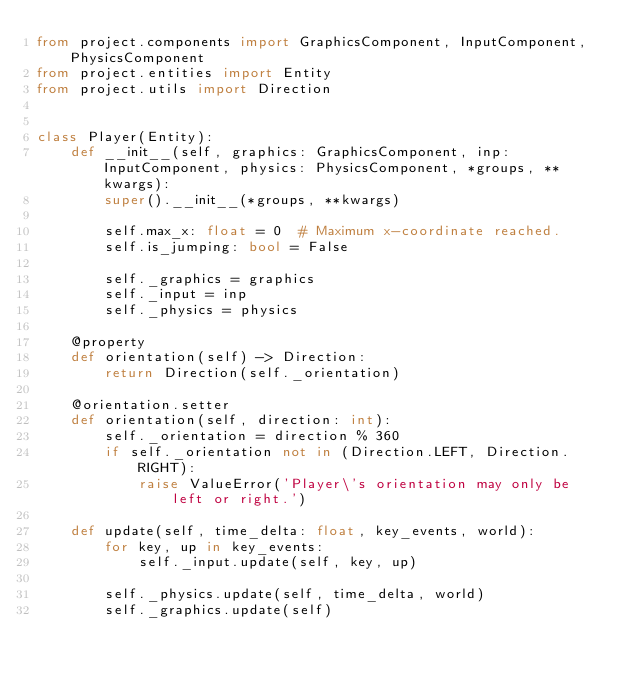Convert code to text. <code><loc_0><loc_0><loc_500><loc_500><_Python_>from project.components import GraphicsComponent, InputComponent, PhysicsComponent
from project.entities import Entity
from project.utils import Direction


class Player(Entity):
    def __init__(self, graphics: GraphicsComponent, inp: InputComponent, physics: PhysicsComponent, *groups, **kwargs):
        super().__init__(*groups, **kwargs)

        self.max_x: float = 0  # Maximum x-coordinate reached.
        self.is_jumping: bool = False

        self._graphics = graphics
        self._input = inp
        self._physics = physics

    @property
    def orientation(self) -> Direction:
        return Direction(self._orientation)

    @orientation.setter
    def orientation(self, direction: int):
        self._orientation = direction % 360
        if self._orientation not in (Direction.LEFT, Direction.RIGHT):
            raise ValueError('Player\'s orientation may only be left or right.')

    def update(self, time_delta: float, key_events, world):
        for key, up in key_events:
            self._input.update(self, key, up)

        self._physics.update(self, time_delta, world)
        self._graphics.update(self)
</code> 